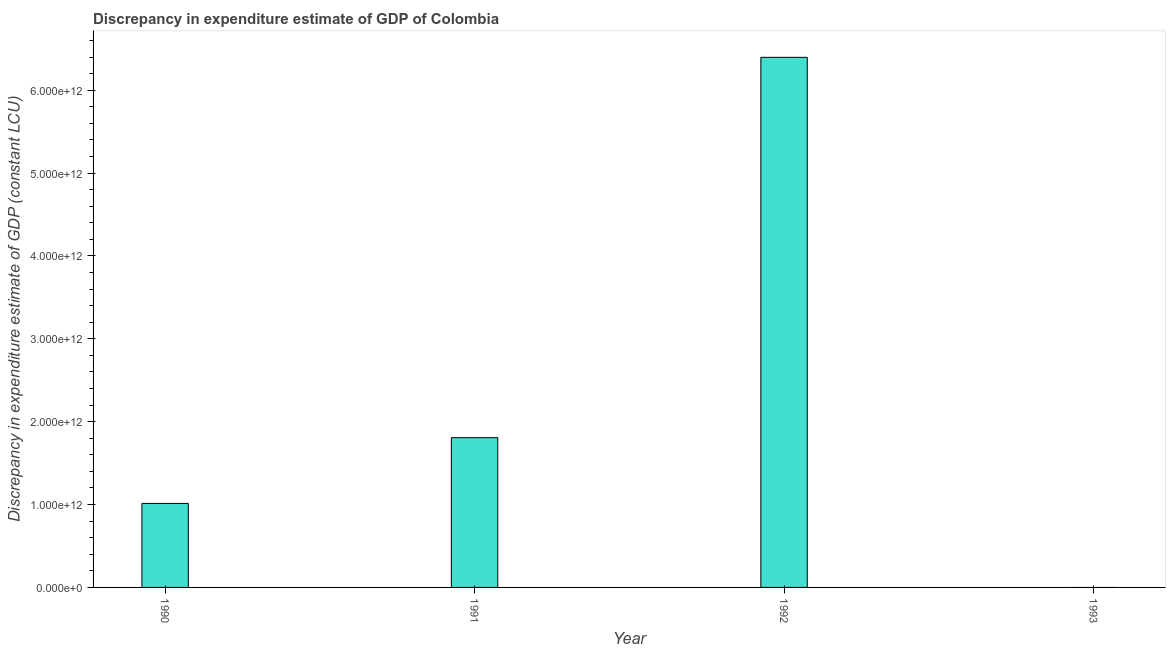Does the graph contain any zero values?
Make the answer very short. Yes. What is the title of the graph?
Make the answer very short. Discrepancy in expenditure estimate of GDP of Colombia. What is the label or title of the Y-axis?
Make the answer very short. Discrepancy in expenditure estimate of GDP (constant LCU). What is the discrepancy in expenditure estimate of gdp in 1992?
Offer a very short reply. 6.40e+12. Across all years, what is the maximum discrepancy in expenditure estimate of gdp?
Ensure brevity in your answer.  6.40e+12. What is the sum of the discrepancy in expenditure estimate of gdp?
Provide a short and direct response. 9.22e+12. What is the difference between the discrepancy in expenditure estimate of gdp in 1990 and 1991?
Offer a terse response. -7.94e+11. What is the average discrepancy in expenditure estimate of gdp per year?
Your answer should be compact. 2.30e+12. What is the median discrepancy in expenditure estimate of gdp?
Keep it short and to the point. 1.41e+12. What is the ratio of the discrepancy in expenditure estimate of gdp in 1990 to that in 1992?
Give a very brief answer. 0.16. Is the discrepancy in expenditure estimate of gdp in 1991 less than that in 1992?
Ensure brevity in your answer.  Yes. What is the difference between the highest and the second highest discrepancy in expenditure estimate of gdp?
Your answer should be compact. 4.59e+12. Is the sum of the discrepancy in expenditure estimate of gdp in 1990 and 1992 greater than the maximum discrepancy in expenditure estimate of gdp across all years?
Ensure brevity in your answer.  Yes. What is the difference between the highest and the lowest discrepancy in expenditure estimate of gdp?
Keep it short and to the point. 6.40e+12. In how many years, is the discrepancy in expenditure estimate of gdp greater than the average discrepancy in expenditure estimate of gdp taken over all years?
Make the answer very short. 1. How many bars are there?
Offer a terse response. 3. What is the difference between two consecutive major ticks on the Y-axis?
Provide a short and direct response. 1.00e+12. Are the values on the major ticks of Y-axis written in scientific E-notation?
Provide a succinct answer. Yes. What is the Discrepancy in expenditure estimate of GDP (constant LCU) in 1990?
Offer a terse response. 1.01e+12. What is the Discrepancy in expenditure estimate of GDP (constant LCU) in 1991?
Provide a succinct answer. 1.81e+12. What is the Discrepancy in expenditure estimate of GDP (constant LCU) in 1992?
Keep it short and to the point. 6.40e+12. What is the difference between the Discrepancy in expenditure estimate of GDP (constant LCU) in 1990 and 1991?
Your answer should be very brief. -7.94e+11. What is the difference between the Discrepancy in expenditure estimate of GDP (constant LCU) in 1990 and 1992?
Offer a very short reply. -5.38e+12. What is the difference between the Discrepancy in expenditure estimate of GDP (constant LCU) in 1991 and 1992?
Offer a terse response. -4.59e+12. What is the ratio of the Discrepancy in expenditure estimate of GDP (constant LCU) in 1990 to that in 1991?
Your answer should be compact. 0.56. What is the ratio of the Discrepancy in expenditure estimate of GDP (constant LCU) in 1990 to that in 1992?
Make the answer very short. 0.16. What is the ratio of the Discrepancy in expenditure estimate of GDP (constant LCU) in 1991 to that in 1992?
Offer a very short reply. 0.28. 